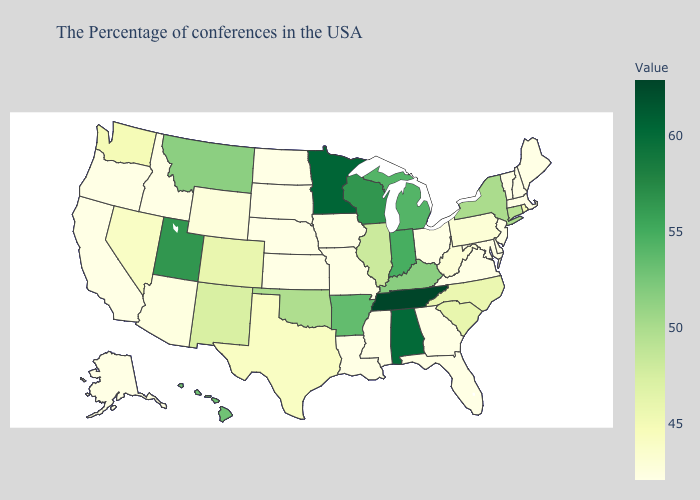Does Maine have the highest value in the USA?
Give a very brief answer. No. Does the map have missing data?
Answer briefly. No. Is the legend a continuous bar?
Answer briefly. Yes. Does North Carolina have a higher value than Illinois?
Concise answer only. No. Does Ohio have the lowest value in the MidWest?
Be succinct. Yes. Which states have the lowest value in the Northeast?
Concise answer only. Maine, Massachusetts, New Hampshire, Vermont, New Jersey. Does the map have missing data?
Give a very brief answer. No. Among the states that border Ohio , does Indiana have the highest value?
Be succinct. Yes. Is the legend a continuous bar?
Quick response, please. Yes. Among the states that border Kentucky , which have the lowest value?
Answer briefly. Virginia, Ohio, Missouri. 